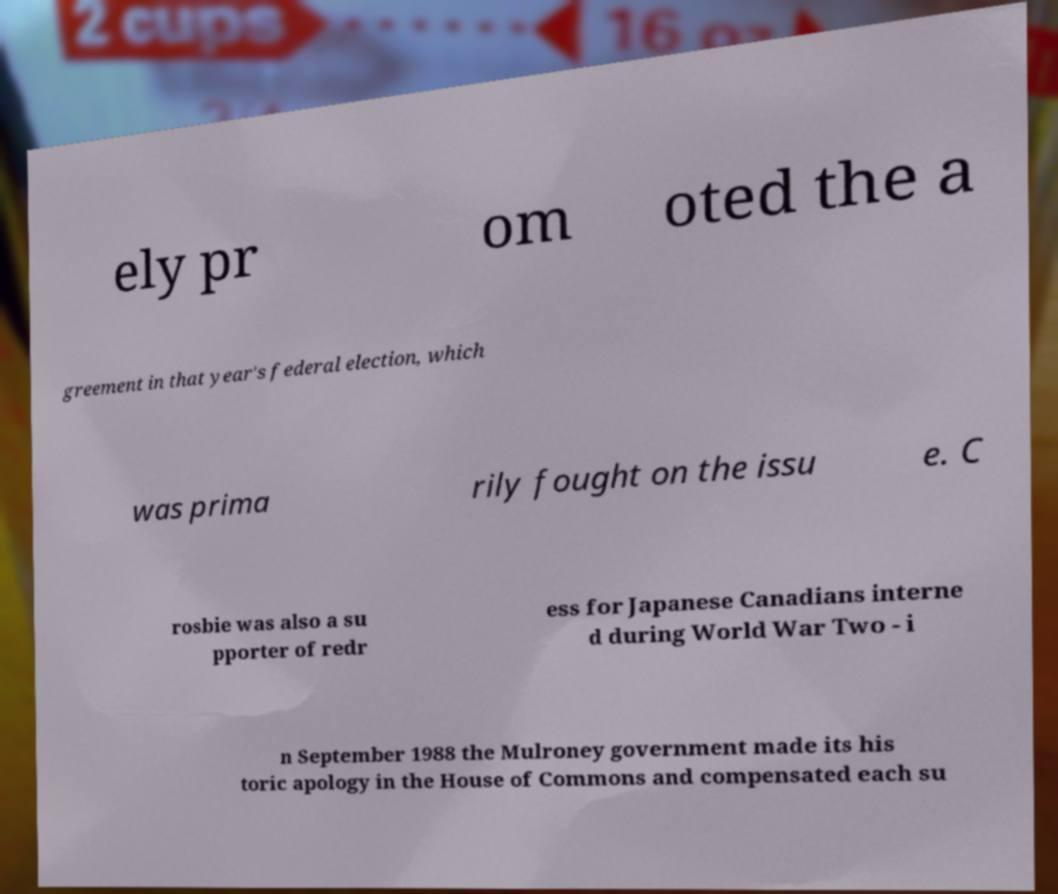Could you assist in decoding the text presented in this image and type it out clearly? ely pr om oted the a greement in that year's federal election, which was prima rily fought on the issu e. C rosbie was also a su pporter of redr ess for Japanese Canadians interne d during World War Two - i n September 1988 the Mulroney government made its his toric apology in the House of Commons and compensated each su 